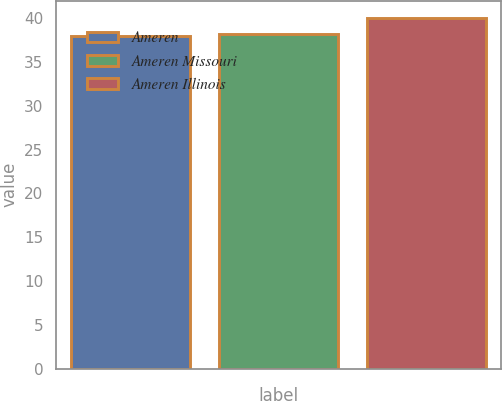<chart> <loc_0><loc_0><loc_500><loc_500><bar_chart><fcel>Ameren<fcel>Ameren Missouri<fcel>Ameren Illinois<nl><fcel>38<fcel>38.2<fcel>40<nl></chart> 